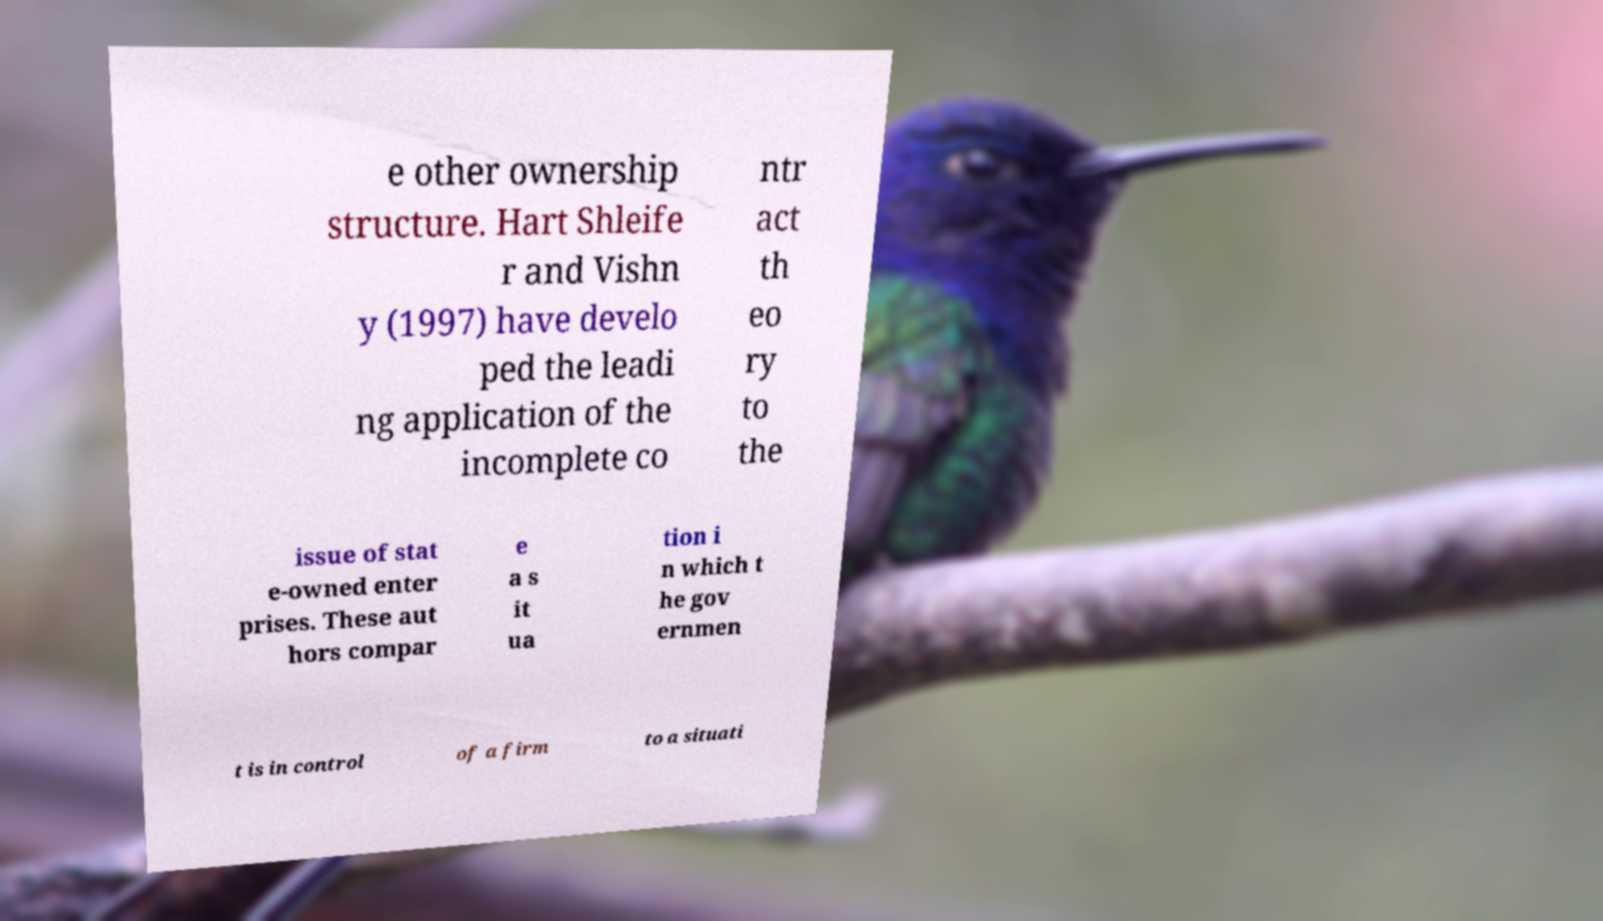There's text embedded in this image that I need extracted. Can you transcribe it verbatim? e other ownership structure. Hart Shleife r and Vishn y (1997) have develo ped the leadi ng application of the incomplete co ntr act th eo ry to the issue of stat e-owned enter prises. These aut hors compar e a s it ua tion i n which t he gov ernmen t is in control of a firm to a situati 